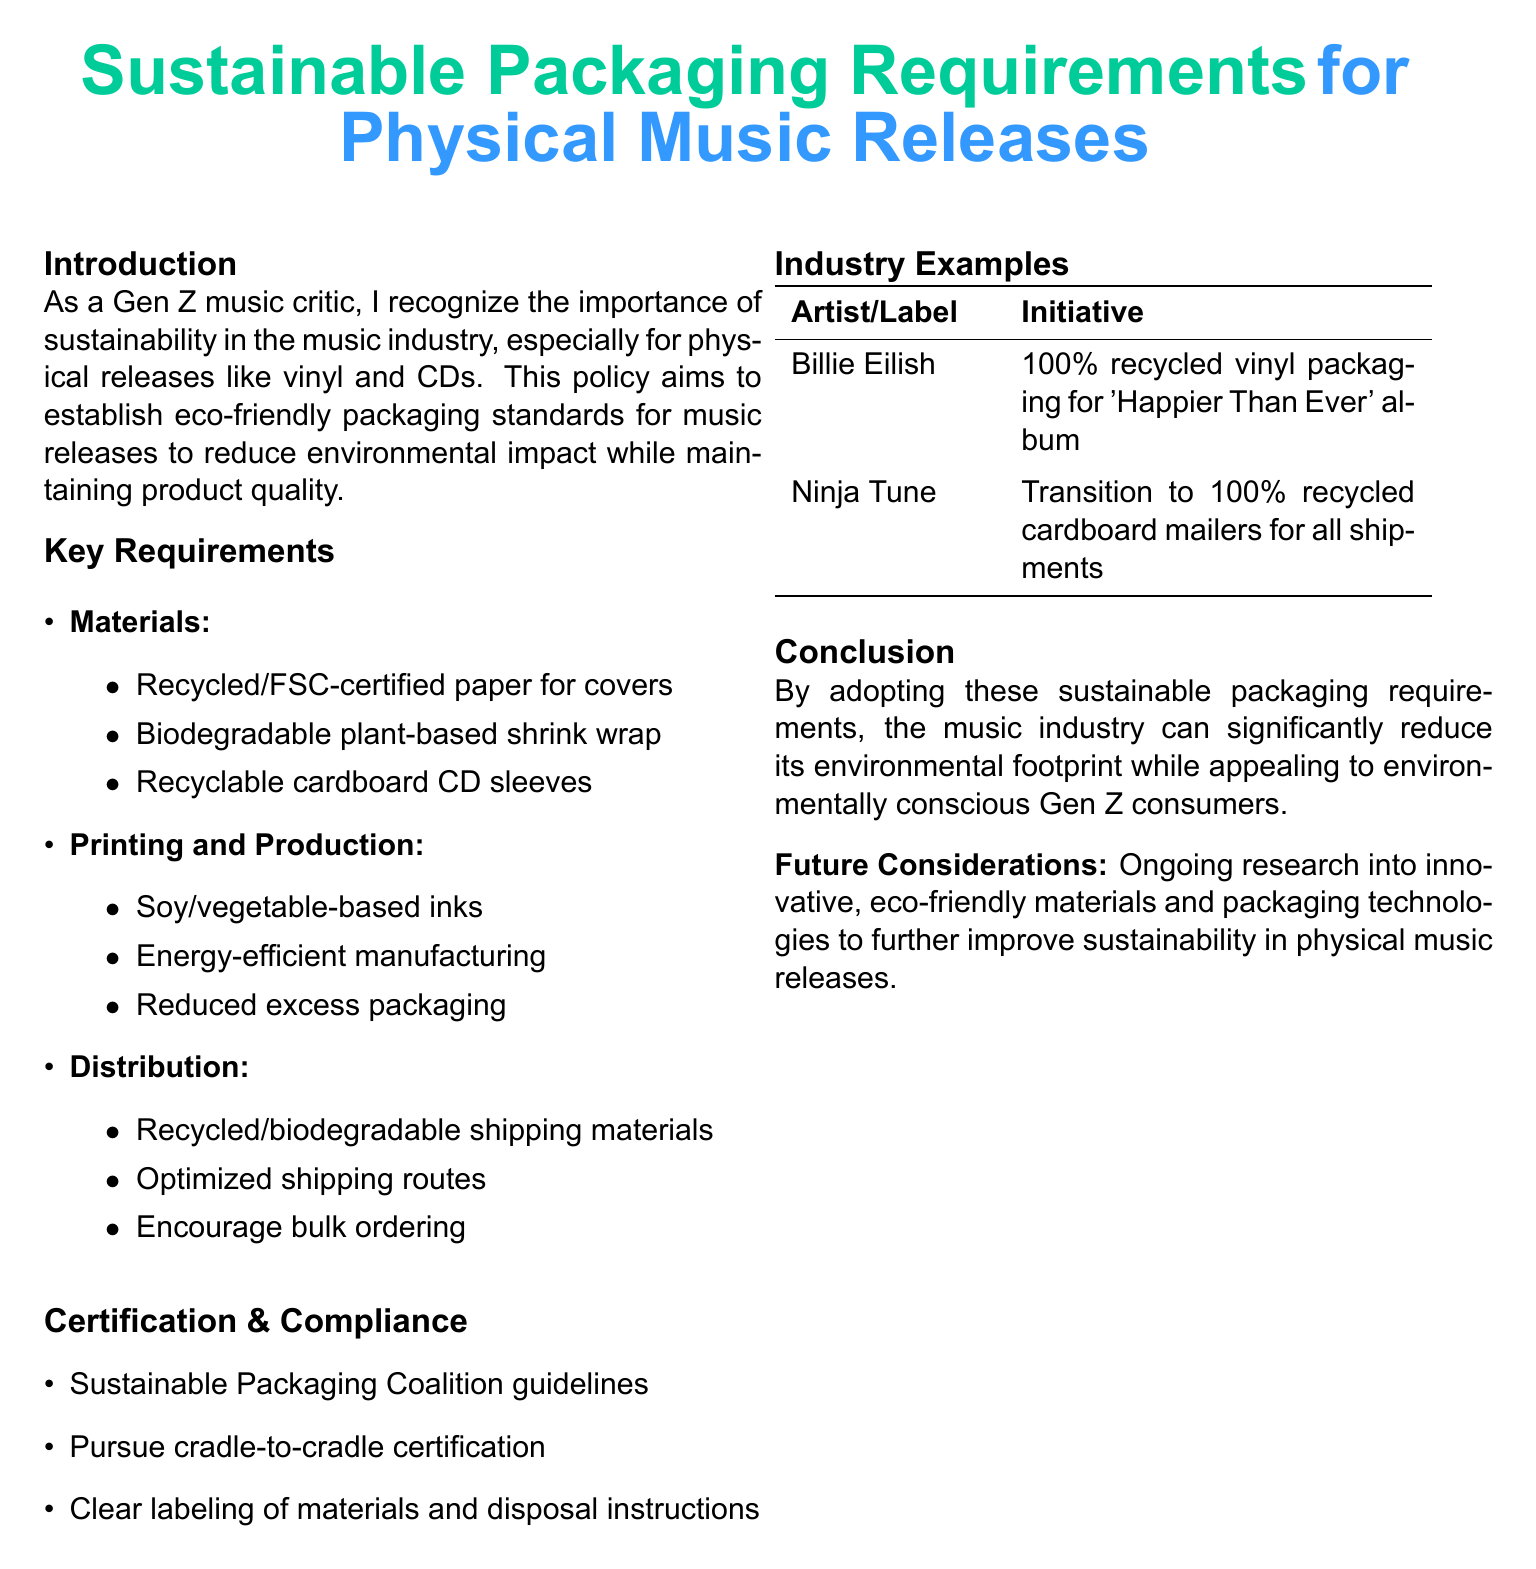What materials are required for covers? The document lists recycled or FSC-certified paper as required materials for covers.
Answer: Recycled/FSC-certified paper What type of shrink wrap is recommended? The policy document specifies biodegradable plant-based shrink wrap as the recommended type.
Answer: Biodegradable plant-based shrink wrap Which printing method is mentioned in the document? Soy or vegetable-based inks are mentioned as the printing method in the key requirements section.
Answer: Soy/vegetable-based inks What initiative did Billie Eilish adopt? The document states that Billie Eilish uses 100% recycled vinyl packaging for her album 'Happier Than Ever'.
Answer: 100% recycled vinyl packaging for 'Happier Than Ever' What certification is suggested for compliance? The document suggests pursuing cradle-to-cradle certification for compliance with sustainable packaging requirements.
Answer: Cradle-to-cradle certification Why is sustainability important in the music industry? The introduction emphasizes the significance of sustainability to reduce environmental impact while maintaining product quality.
Answer: To reduce environmental impact What shipping materials should be used according to the document? The policy indicates the use of recycled or biodegradable shipping materials.
Answer: Recycled/biodegradable shipping materials What does the document aim to establish? The policy aims to establish eco-friendly packaging standards for music releases.
Answer: Eco-friendly packaging standards 